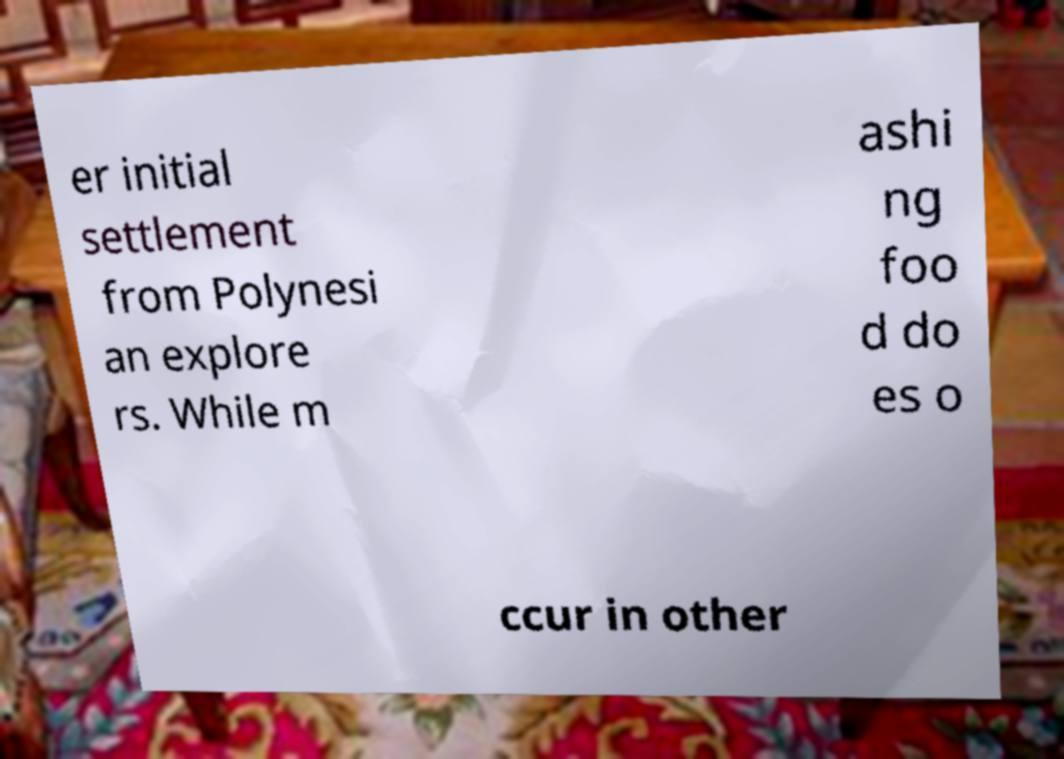What messages or text are displayed in this image? I need them in a readable, typed format. er initial settlement from Polynesi an explore rs. While m ashi ng foo d do es o ccur in other 